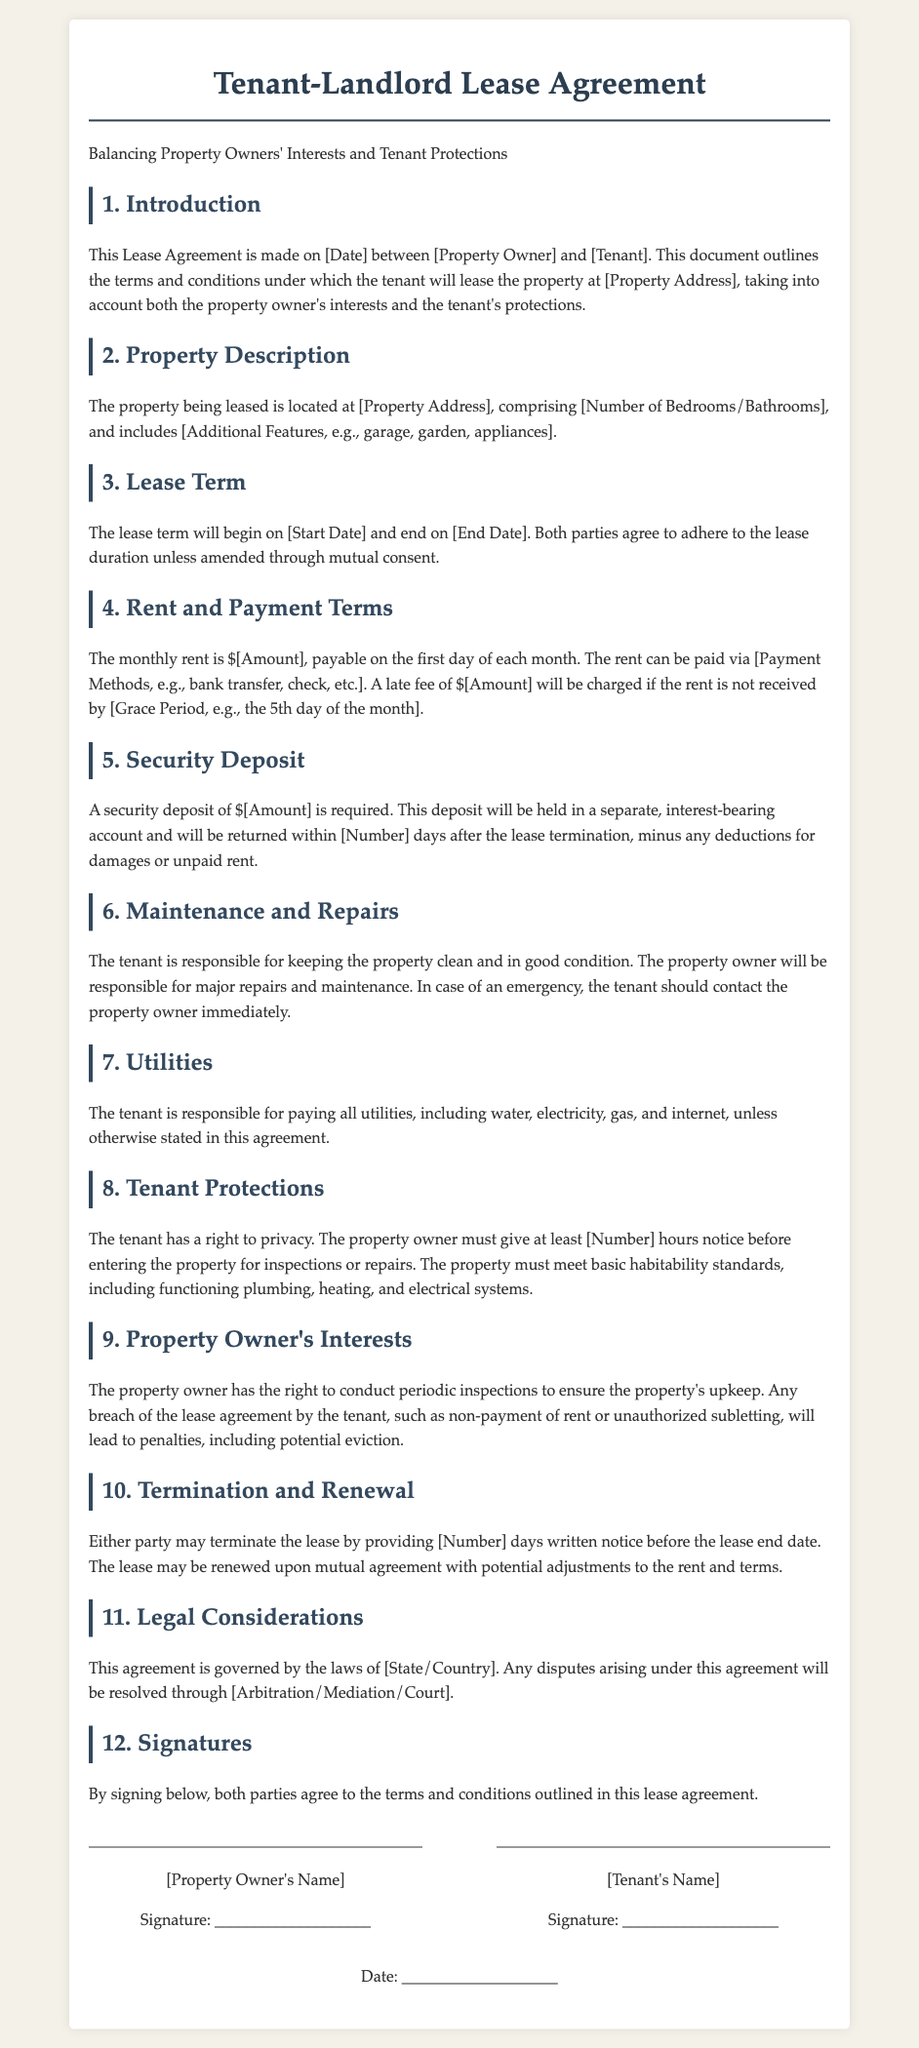What is the lease term duration? The lease term duration is defined in the document, specifying the start and end dates.
Answer: [Start Date] to [End Date] Who is responsible for major repairs? The document outlines responsibilities, stating that the property owner is responsible for major repairs and maintenance.
Answer: Property Owner What is the security deposit amount? The security deposit amount is specified in the respective section of the document.
Answer: $[Amount] How much is the monthly rent? The document explicitly states the amount for monthly rent to be paid by the tenant.
Answer: $[Amount] What notice is required for lease termination? The document indicates the number of days written notice required for lease termination.
Answer: [Number] days What are the tenant's utility payment responsibilities? The document specifies which parties are responsible for paying utilities.
Answer: Tenant What is the tenant's right regarding property access? The document dictates a notice requirement for property access by the owner.
Answer: [Number] hours What can happen if the tenant breaches the lease? The document outlines penalties for breaches of the lease agreement.
Answer: Potential eviction What governs this lease agreement? The legal jurisdiction governing the lease is stated in the document.
Answer: [State/Country] 